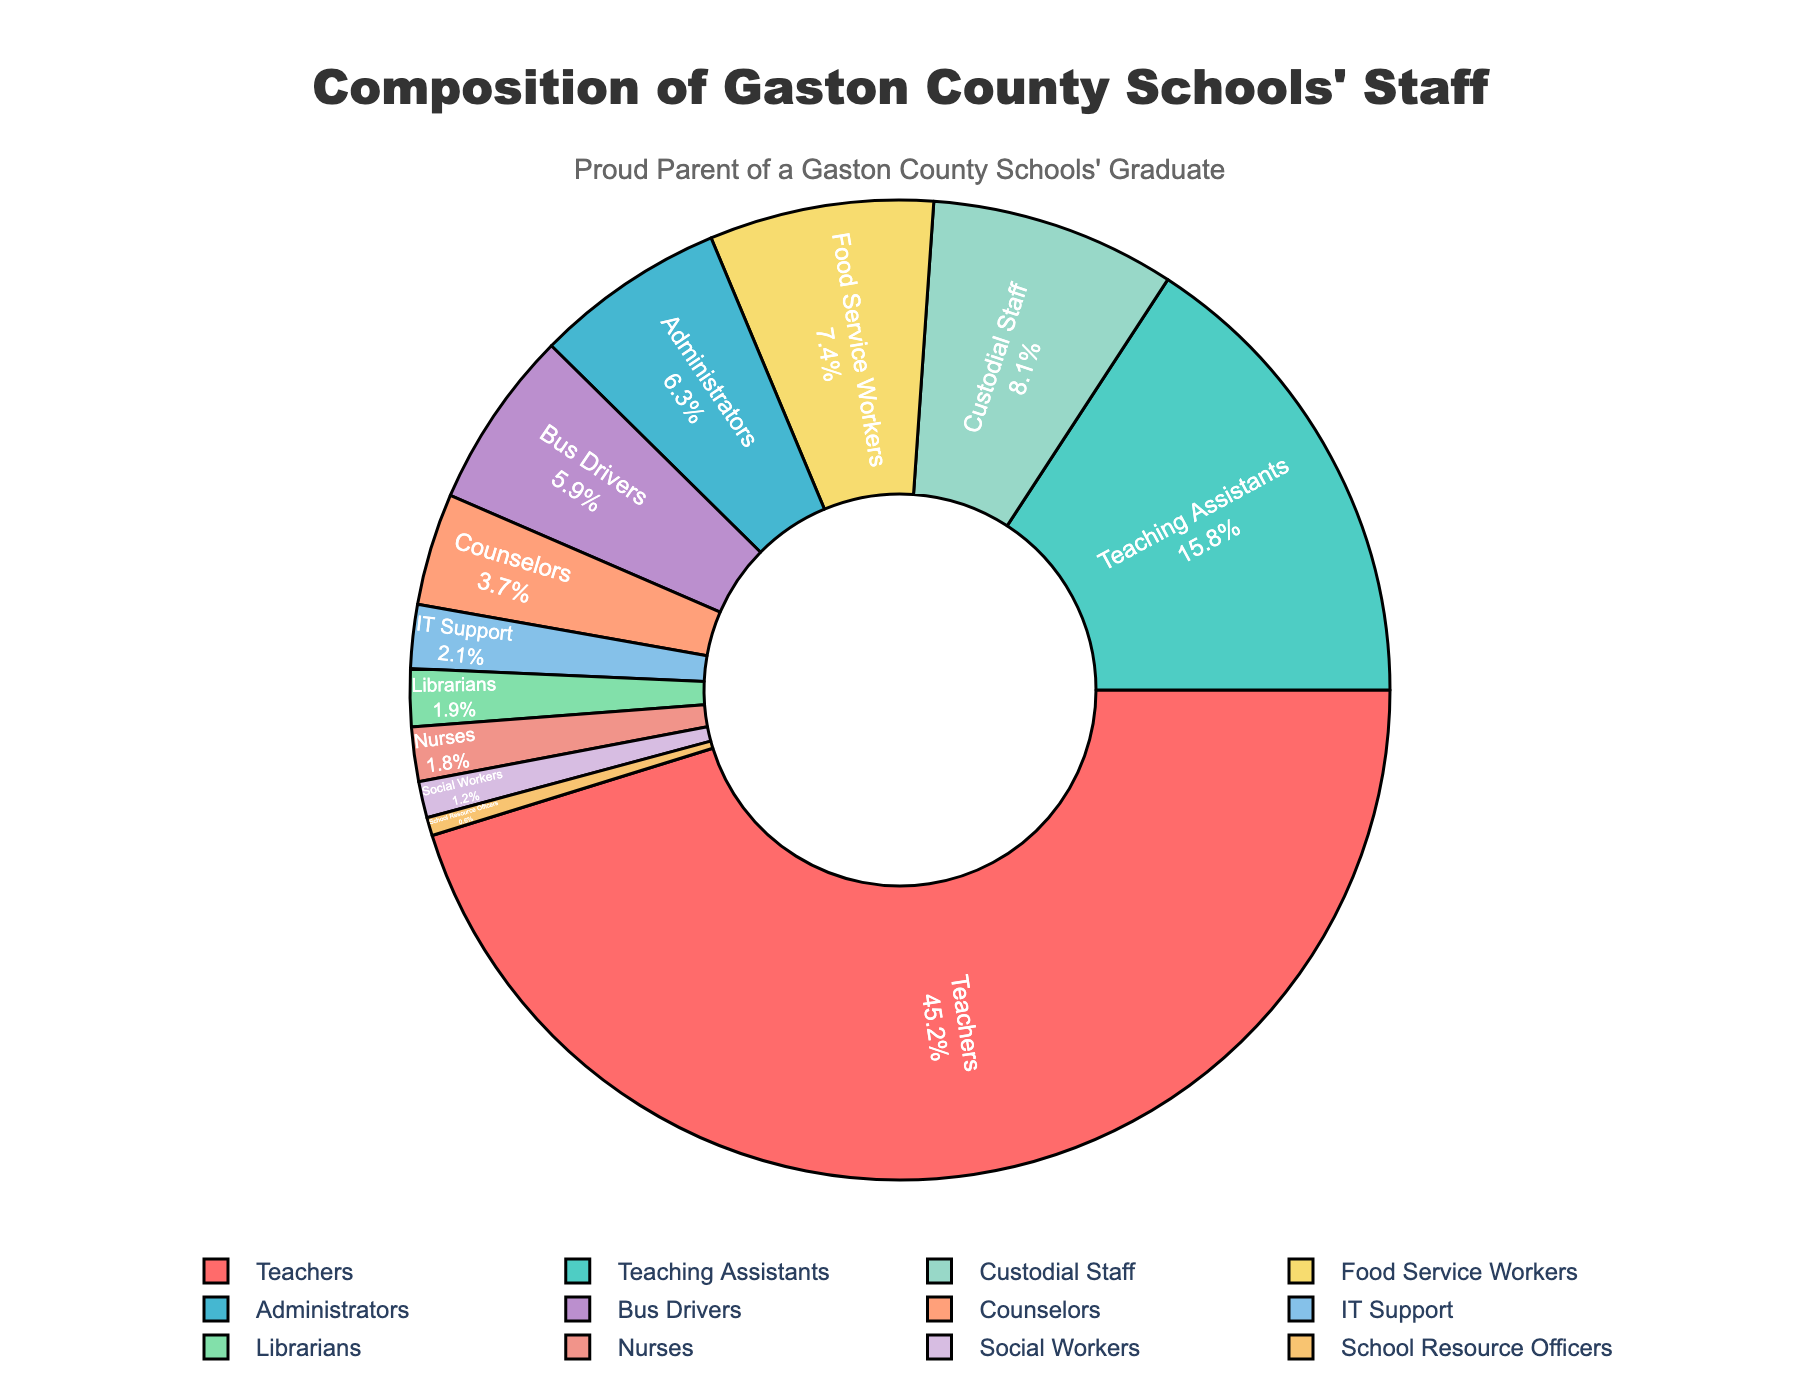what percentage of staff are involved directly in teaching (teachers + teaching assistants)? Add the percentages of Teachers (45.2%) and Teaching Assistants (15.8%). The sum is 45.2 + 15.8 = 61.0%
Answer: 61.0% Which role has the smallest representation in Gaston County Schools' staff? The smallest percentage shown on the pie chart is 0.6%, which corresponds to School Resource Officers.
Answer: School Resource Officers How many roles have a percentage greater than 10%? Examine each segment of the pie chart to see if the percentage exceeds 10%. Only Teachers (45.2%) fit this criterion.
Answer: 1 Which two roles together make up the smallest percentages? Identify the two smallest percentages: School Resource Officers (0.6%) and Social Workers (1.2%). Adding these gives 0.6 + 1.2 = 1.8%
Answer: School Resource Officers and Social Workers What is the percentage difference between Custodial Staff and Food Service Workers? Subtract the percentage of Food Service Workers (7.4%) from Custodial Staff (8.1%). The difference is 8.1 - 7.4 = 0.7%
Answer: 0.7% Compare the percentages of Bus Drivers and IT Support. Which one is higher? Bus Drivers have a percentage of 5.9% while IT Support has 2.1%. Thus, Bus Drivers have a higher percentage.
Answer: Bus Drivers Which role, indicated by a unique color near green, has a non-zero percentage but less than 2%? The role near green but less than 2% is Nurses at 1.8%.
Answer: Nurses How do the percentages of Librarians and Counselors compare? Librarians have a percentage of 1.9% and Counselors have 3.7%. Therefore, Counselors have a higher percentage.
Answer: Counselors If another role were to be added to match the percentage of Nurses, what would be the combined percentage of this new role and the existing Nurses role? Nurses have a percentage of 1.8%. Adding another identical percentage gives 1.8 + 1.8 = 3.6%
Answer: 3.6% Which role has a percentage that is closest to the average of the percentages for Bus Drivers and Librarians? Find the average of Bus Drivers (5.9%) and Librarians (1.9%). The average is (5.9 + 1.9) / 2 = 3.9%. The role closest to this average is Counselors at 3.7%.
Answer: Counselors 